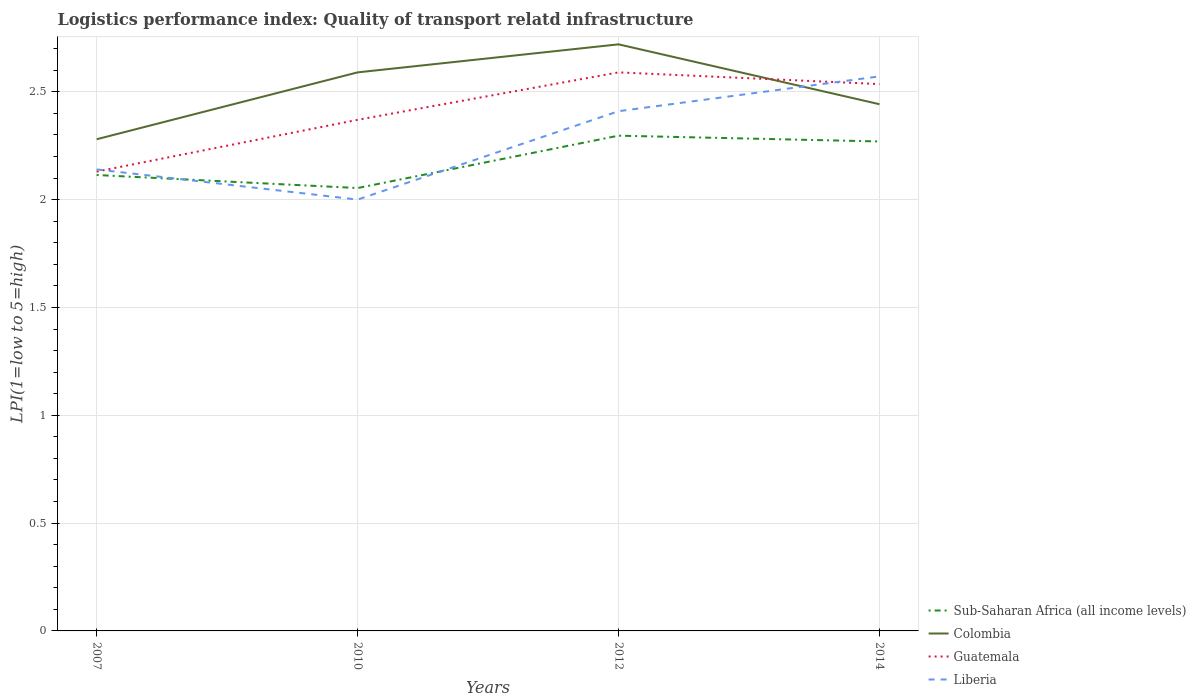Does the line corresponding to Guatemala intersect with the line corresponding to Sub-Saharan Africa (all income levels)?
Provide a short and direct response. No. Is the number of lines equal to the number of legend labels?
Your answer should be compact. Yes. In which year was the logistics performance index in Guatemala maximum?
Your answer should be very brief. 2007. What is the total logistics performance index in Liberia in the graph?
Ensure brevity in your answer.  -0.27. What is the difference between the highest and the second highest logistics performance index in Guatemala?
Offer a terse response. 0.46. What is the difference between the highest and the lowest logistics performance index in Sub-Saharan Africa (all income levels)?
Give a very brief answer. 2. Is the logistics performance index in Guatemala strictly greater than the logistics performance index in Sub-Saharan Africa (all income levels) over the years?
Give a very brief answer. No. What is the difference between two consecutive major ticks on the Y-axis?
Provide a short and direct response. 0.5. Are the values on the major ticks of Y-axis written in scientific E-notation?
Provide a succinct answer. No. Does the graph contain any zero values?
Make the answer very short. No. How many legend labels are there?
Your answer should be compact. 4. What is the title of the graph?
Give a very brief answer. Logistics performance index: Quality of transport relatd infrastructure. What is the label or title of the X-axis?
Make the answer very short. Years. What is the label or title of the Y-axis?
Your response must be concise. LPI(1=low to 5=high). What is the LPI(1=low to 5=high) of Sub-Saharan Africa (all income levels) in 2007?
Keep it short and to the point. 2.11. What is the LPI(1=low to 5=high) of Colombia in 2007?
Ensure brevity in your answer.  2.28. What is the LPI(1=low to 5=high) of Guatemala in 2007?
Keep it short and to the point. 2.13. What is the LPI(1=low to 5=high) in Liberia in 2007?
Ensure brevity in your answer.  2.14. What is the LPI(1=low to 5=high) of Sub-Saharan Africa (all income levels) in 2010?
Provide a succinct answer. 2.05. What is the LPI(1=low to 5=high) in Colombia in 2010?
Provide a short and direct response. 2.59. What is the LPI(1=low to 5=high) in Guatemala in 2010?
Provide a succinct answer. 2.37. What is the LPI(1=low to 5=high) of Sub-Saharan Africa (all income levels) in 2012?
Provide a short and direct response. 2.3. What is the LPI(1=low to 5=high) in Colombia in 2012?
Your answer should be compact. 2.72. What is the LPI(1=low to 5=high) of Guatemala in 2012?
Offer a very short reply. 2.59. What is the LPI(1=low to 5=high) in Liberia in 2012?
Offer a very short reply. 2.41. What is the LPI(1=low to 5=high) of Sub-Saharan Africa (all income levels) in 2014?
Offer a very short reply. 2.27. What is the LPI(1=low to 5=high) in Colombia in 2014?
Your answer should be compact. 2.44. What is the LPI(1=low to 5=high) in Guatemala in 2014?
Ensure brevity in your answer.  2.54. What is the LPI(1=low to 5=high) of Liberia in 2014?
Ensure brevity in your answer.  2.57. Across all years, what is the maximum LPI(1=low to 5=high) in Sub-Saharan Africa (all income levels)?
Ensure brevity in your answer.  2.3. Across all years, what is the maximum LPI(1=low to 5=high) of Colombia?
Give a very brief answer. 2.72. Across all years, what is the maximum LPI(1=low to 5=high) of Guatemala?
Provide a short and direct response. 2.59. Across all years, what is the maximum LPI(1=low to 5=high) in Liberia?
Provide a short and direct response. 2.57. Across all years, what is the minimum LPI(1=low to 5=high) in Sub-Saharan Africa (all income levels)?
Your answer should be very brief. 2.05. Across all years, what is the minimum LPI(1=low to 5=high) of Colombia?
Your answer should be very brief. 2.28. Across all years, what is the minimum LPI(1=low to 5=high) in Guatemala?
Your response must be concise. 2.13. Across all years, what is the minimum LPI(1=low to 5=high) in Liberia?
Offer a very short reply. 2. What is the total LPI(1=low to 5=high) in Sub-Saharan Africa (all income levels) in the graph?
Offer a terse response. 8.73. What is the total LPI(1=low to 5=high) in Colombia in the graph?
Provide a succinct answer. 10.03. What is the total LPI(1=low to 5=high) in Guatemala in the graph?
Your answer should be very brief. 9.63. What is the total LPI(1=low to 5=high) of Liberia in the graph?
Your answer should be compact. 9.12. What is the difference between the LPI(1=low to 5=high) of Sub-Saharan Africa (all income levels) in 2007 and that in 2010?
Offer a terse response. 0.06. What is the difference between the LPI(1=low to 5=high) of Colombia in 2007 and that in 2010?
Your response must be concise. -0.31. What is the difference between the LPI(1=low to 5=high) in Guatemala in 2007 and that in 2010?
Your response must be concise. -0.24. What is the difference between the LPI(1=low to 5=high) of Liberia in 2007 and that in 2010?
Your response must be concise. 0.14. What is the difference between the LPI(1=low to 5=high) of Sub-Saharan Africa (all income levels) in 2007 and that in 2012?
Make the answer very short. -0.18. What is the difference between the LPI(1=low to 5=high) of Colombia in 2007 and that in 2012?
Offer a very short reply. -0.44. What is the difference between the LPI(1=low to 5=high) in Guatemala in 2007 and that in 2012?
Offer a terse response. -0.46. What is the difference between the LPI(1=low to 5=high) of Liberia in 2007 and that in 2012?
Give a very brief answer. -0.27. What is the difference between the LPI(1=low to 5=high) in Sub-Saharan Africa (all income levels) in 2007 and that in 2014?
Keep it short and to the point. -0.16. What is the difference between the LPI(1=low to 5=high) in Colombia in 2007 and that in 2014?
Your answer should be very brief. -0.16. What is the difference between the LPI(1=low to 5=high) of Guatemala in 2007 and that in 2014?
Give a very brief answer. -0.41. What is the difference between the LPI(1=low to 5=high) in Liberia in 2007 and that in 2014?
Offer a very short reply. -0.43. What is the difference between the LPI(1=low to 5=high) of Sub-Saharan Africa (all income levels) in 2010 and that in 2012?
Make the answer very short. -0.24. What is the difference between the LPI(1=low to 5=high) in Colombia in 2010 and that in 2012?
Your answer should be compact. -0.13. What is the difference between the LPI(1=low to 5=high) of Guatemala in 2010 and that in 2012?
Your response must be concise. -0.22. What is the difference between the LPI(1=low to 5=high) in Liberia in 2010 and that in 2012?
Give a very brief answer. -0.41. What is the difference between the LPI(1=low to 5=high) in Sub-Saharan Africa (all income levels) in 2010 and that in 2014?
Your response must be concise. -0.22. What is the difference between the LPI(1=low to 5=high) in Colombia in 2010 and that in 2014?
Provide a short and direct response. 0.15. What is the difference between the LPI(1=low to 5=high) of Guatemala in 2010 and that in 2014?
Keep it short and to the point. -0.17. What is the difference between the LPI(1=low to 5=high) of Liberia in 2010 and that in 2014?
Offer a very short reply. -0.57. What is the difference between the LPI(1=low to 5=high) of Sub-Saharan Africa (all income levels) in 2012 and that in 2014?
Ensure brevity in your answer.  0.03. What is the difference between the LPI(1=low to 5=high) in Colombia in 2012 and that in 2014?
Your answer should be compact. 0.28. What is the difference between the LPI(1=low to 5=high) of Guatemala in 2012 and that in 2014?
Offer a very short reply. 0.05. What is the difference between the LPI(1=low to 5=high) of Liberia in 2012 and that in 2014?
Your response must be concise. -0.16. What is the difference between the LPI(1=low to 5=high) of Sub-Saharan Africa (all income levels) in 2007 and the LPI(1=low to 5=high) of Colombia in 2010?
Provide a short and direct response. -0.48. What is the difference between the LPI(1=low to 5=high) of Sub-Saharan Africa (all income levels) in 2007 and the LPI(1=low to 5=high) of Guatemala in 2010?
Provide a succinct answer. -0.26. What is the difference between the LPI(1=low to 5=high) of Sub-Saharan Africa (all income levels) in 2007 and the LPI(1=low to 5=high) of Liberia in 2010?
Your answer should be compact. 0.11. What is the difference between the LPI(1=low to 5=high) of Colombia in 2007 and the LPI(1=low to 5=high) of Guatemala in 2010?
Offer a very short reply. -0.09. What is the difference between the LPI(1=low to 5=high) of Colombia in 2007 and the LPI(1=low to 5=high) of Liberia in 2010?
Offer a very short reply. 0.28. What is the difference between the LPI(1=low to 5=high) of Guatemala in 2007 and the LPI(1=low to 5=high) of Liberia in 2010?
Give a very brief answer. 0.13. What is the difference between the LPI(1=low to 5=high) in Sub-Saharan Africa (all income levels) in 2007 and the LPI(1=low to 5=high) in Colombia in 2012?
Your answer should be very brief. -0.61. What is the difference between the LPI(1=low to 5=high) in Sub-Saharan Africa (all income levels) in 2007 and the LPI(1=low to 5=high) in Guatemala in 2012?
Your answer should be very brief. -0.48. What is the difference between the LPI(1=low to 5=high) of Sub-Saharan Africa (all income levels) in 2007 and the LPI(1=low to 5=high) of Liberia in 2012?
Provide a succinct answer. -0.3. What is the difference between the LPI(1=low to 5=high) of Colombia in 2007 and the LPI(1=low to 5=high) of Guatemala in 2012?
Keep it short and to the point. -0.31. What is the difference between the LPI(1=low to 5=high) in Colombia in 2007 and the LPI(1=low to 5=high) in Liberia in 2012?
Your response must be concise. -0.13. What is the difference between the LPI(1=low to 5=high) of Guatemala in 2007 and the LPI(1=low to 5=high) of Liberia in 2012?
Offer a terse response. -0.28. What is the difference between the LPI(1=low to 5=high) in Sub-Saharan Africa (all income levels) in 2007 and the LPI(1=low to 5=high) in Colombia in 2014?
Your answer should be very brief. -0.33. What is the difference between the LPI(1=low to 5=high) in Sub-Saharan Africa (all income levels) in 2007 and the LPI(1=low to 5=high) in Guatemala in 2014?
Keep it short and to the point. -0.42. What is the difference between the LPI(1=low to 5=high) of Sub-Saharan Africa (all income levels) in 2007 and the LPI(1=low to 5=high) of Liberia in 2014?
Offer a terse response. -0.46. What is the difference between the LPI(1=low to 5=high) in Colombia in 2007 and the LPI(1=low to 5=high) in Guatemala in 2014?
Your answer should be compact. -0.26. What is the difference between the LPI(1=low to 5=high) in Colombia in 2007 and the LPI(1=low to 5=high) in Liberia in 2014?
Ensure brevity in your answer.  -0.29. What is the difference between the LPI(1=low to 5=high) in Guatemala in 2007 and the LPI(1=low to 5=high) in Liberia in 2014?
Offer a terse response. -0.44. What is the difference between the LPI(1=low to 5=high) in Sub-Saharan Africa (all income levels) in 2010 and the LPI(1=low to 5=high) in Colombia in 2012?
Provide a succinct answer. -0.67. What is the difference between the LPI(1=low to 5=high) in Sub-Saharan Africa (all income levels) in 2010 and the LPI(1=low to 5=high) in Guatemala in 2012?
Provide a short and direct response. -0.54. What is the difference between the LPI(1=low to 5=high) of Sub-Saharan Africa (all income levels) in 2010 and the LPI(1=low to 5=high) of Liberia in 2012?
Make the answer very short. -0.36. What is the difference between the LPI(1=low to 5=high) of Colombia in 2010 and the LPI(1=low to 5=high) of Guatemala in 2012?
Your answer should be very brief. 0. What is the difference between the LPI(1=low to 5=high) in Colombia in 2010 and the LPI(1=low to 5=high) in Liberia in 2012?
Offer a terse response. 0.18. What is the difference between the LPI(1=low to 5=high) of Guatemala in 2010 and the LPI(1=low to 5=high) of Liberia in 2012?
Make the answer very short. -0.04. What is the difference between the LPI(1=low to 5=high) in Sub-Saharan Africa (all income levels) in 2010 and the LPI(1=low to 5=high) in Colombia in 2014?
Offer a very short reply. -0.39. What is the difference between the LPI(1=low to 5=high) in Sub-Saharan Africa (all income levels) in 2010 and the LPI(1=low to 5=high) in Guatemala in 2014?
Offer a terse response. -0.48. What is the difference between the LPI(1=low to 5=high) of Sub-Saharan Africa (all income levels) in 2010 and the LPI(1=low to 5=high) of Liberia in 2014?
Your answer should be very brief. -0.52. What is the difference between the LPI(1=low to 5=high) in Colombia in 2010 and the LPI(1=low to 5=high) in Guatemala in 2014?
Give a very brief answer. 0.05. What is the difference between the LPI(1=low to 5=high) in Colombia in 2010 and the LPI(1=low to 5=high) in Liberia in 2014?
Offer a very short reply. 0.02. What is the difference between the LPI(1=low to 5=high) in Guatemala in 2010 and the LPI(1=low to 5=high) in Liberia in 2014?
Provide a short and direct response. -0.2. What is the difference between the LPI(1=low to 5=high) of Sub-Saharan Africa (all income levels) in 2012 and the LPI(1=low to 5=high) of Colombia in 2014?
Your response must be concise. -0.15. What is the difference between the LPI(1=low to 5=high) in Sub-Saharan Africa (all income levels) in 2012 and the LPI(1=low to 5=high) in Guatemala in 2014?
Keep it short and to the point. -0.24. What is the difference between the LPI(1=low to 5=high) of Sub-Saharan Africa (all income levels) in 2012 and the LPI(1=low to 5=high) of Liberia in 2014?
Offer a terse response. -0.27. What is the difference between the LPI(1=low to 5=high) in Colombia in 2012 and the LPI(1=low to 5=high) in Guatemala in 2014?
Ensure brevity in your answer.  0.18. What is the difference between the LPI(1=low to 5=high) of Colombia in 2012 and the LPI(1=low to 5=high) of Liberia in 2014?
Keep it short and to the point. 0.15. What is the difference between the LPI(1=low to 5=high) in Guatemala in 2012 and the LPI(1=low to 5=high) in Liberia in 2014?
Your response must be concise. 0.02. What is the average LPI(1=low to 5=high) in Sub-Saharan Africa (all income levels) per year?
Provide a succinct answer. 2.18. What is the average LPI(1=low to 5=high) of Colombia per year?
Provide a succinct answer. 2.51. What is the average LPI(1=low to 5=high) of Guatemala per year?
Your response must be concise. 2.41. What is the average LPI(1=low to 5=high) in Liberia per year?
Your answer should be compact. 2.28. In the year 2007, what is the difference between the LPI(1=low to 5=high) in Sub-Saharan Africa (all income levels) and LPI(1=low to 5=high) in Colombia?
Your answer should be compact. -0.17. In the year 2007, what is the difference between the LPI(1=low to 5=high) in Sub-Saharan Africa (all income levels) and LPI(1=low to 5=high) in Guatemala?
Your answer should be compact. -0.02. In the year 2007, what is the difference between the LPI(1=low to 5=high) of Sub-Saharan Africa (all income levels) and LPI(1=low to 5=high) of Liberia?
Give a very brief answer. -0.03. In the year 2007, what is the difference between the LPI(1=low to 5=high) in Colombia and LPI(1=low to 5=high) in Guatemala?
Your answer should be compact. 0.15. In the year 2007, what is the difference between the LPI(1=low to 5=high) of Colombia and LPI(1=low to 5=high) of Liberia?
Your answer should be compact. 0.14. In the year 2007, what is the difference between the LPI(1=low to 5=high) of Guatemala and LPI(1=low to 5=high) of Liberia?
Your answer should be compact. -0.01. In the year 2010, what is the difference between the LPI(1=low to 5=high) of Sub-Saharan Africa (all income levels) and LPI(1=low to 5=high) of Colombia?
Offer a very short reply. -0.54. In the year 2010, what is the difference between the LPI(1=low to 5=high) of Sub-Saharan Africa (all income levels) and LPI(1=low to 5=high) of Guatemala?
Your answer should be very brief. -0.32. In the year 2010, what is the difference between the LPI(1=low to 5=high) of Sub-Saharan Africa (all income levels) and LPI(1=low to 5=high) of Liberia?
Your response must be concise. 0.05. In the year 2010, what is the difference between the LPI(1=low to 5=high) of Colombia and LPI(1=low to 5=high) of Guatemala?
Your answer should be very brief. 0.22. In the year 2010, what is the difference between the LPI(1=low to 5=high) of Colombia and LPI(1=low to 5=high) of Liberia?
Provide a short and direct response. 0.59. In the year 2010, what is the difference between the LPI(1=low to 5=high) in Guatemala and LPI(1=low to 5=high) in Liberia?
Provide a short and direct response. 0.37. In the year 2012, what is the difference between the LPI(1=low to 5=high) in Sub-Saharan Africa (all income levels) and LPI(1=low to 5=high) in Colombia?
Provide a short and direct response. -0.42. In the year 2012, what is the difference between the LPI(1=low to 5=high) of Sub-Saharan Africa (all income levels) and LPI(1=low to 5=high) of Guatemala?
Provide a short and direct response. -0.29. In the year 2012, what is the difference between the LPI(1=low to 5=high) of Sub-Saharan Africa (all income levels) and LPI(1=low to 5=high) of Liberia?
Make the answer very short. -0.11. In the year 2012, what is the difference between the LPI(1=low to 5=high) of Colombia and LPI(1=low to 5=high) of Guatemala?
Keep it short and to the point. 0.13. In the year 2012, what is the difference between the LPI(1=low to 5=high) in Colombia and LPI(1=low to 5=high) in Liberia?
Offer a very short reply. 0.31. In the year 2012, what is the difference between the LPI(1=low to 5=high) of Guatemala and LPI(1=low to 5=high) of Liberia?
Keep it short and to the point. 0.18. In the year 2014, what is the difference between the LPI(1=low to 5=high) in Sub-Saharan Africa (all income levels) and LPI(1=low to 5=high) in Colombia?
Your answer should be very brief. -0.17. In the year 2014, what is the difference between the LPI(1=low to 5=high) of Sub-Saharan Africa (all income levels) and LPI(1=low to 5=high) of Guatemala?
Your answer should be compact. -0.27. In the year 2014, what is the difference between the LPI(1=low to 5=high) in Sub-Saharan Africa (all income levels) and LPI(1=low to 5=high) in Liberia?
Ensure brevity in your answer.  -0.3. In the year 2014, what is the difference between the LPI(1=low to 5=high) in Colombia and LPI(1=low to 5=high) in Guatemala?
Ensure brevity in your answer.  -0.09. In the year 2014, what is the difference between the LPI(1=low to 5=high) of Colombia and LPI(1=low to 5=high) of Liberia?
Keep it short and to the point. -0.13. In the year 2014, what is the difference between the LPI(1=low to 5=high) of Guatemala and LPI(1=low to 5=high) of Liberia?
Ensure brevity in your answer.  -0.04. What is the ratio of the LPI(1=low to 5=high) of Sub-Saharan Africa (all income levels) in 2007 to that in 2010?
Offer a terse response. 1.03. What is the ratio of the LPI(1=low to 5=high) in Colombia in 2007 to that in 2010?
Keep it short and to the point. 0.88. What is the ratio of the LPI(1=low to 5=high) in Guatemala in 2007 to that in 2010?
Give a very brief answer. 0.9. What is the ratio of the LPI(1=low to 5=high) in Liberia in 2007 to that in 2010?
Make the answer very short. 1.07. What is the ratio of the LPI(1=low to 5=high) of Sub-Saharan Africa (all income levels) in 2007 to that in 2012?
Give a very brief answer. 0.92. What is the ratio of the LPI(1=low to 5=high) in Colombia in 2007 to that in 2012?
Your answer should be compact. 0.84. What is the ratio of the LPI(1=low to 5=high) of Guatemala in 2007 to that in 2012?
Provide a succinct answer. 0.82. What is the ratio of the LPI(1=low to 5=high) in Liberia in 2007 to that in 2012?
Offer a terse response. 0.89. What is the ratio of the LPI(1=low to 5=high) of Sub-Saharan Africa (all income levels) in 2007 to that in 2014?
Your answer should be very brief. 0.93. What is the ratio of the LPI(1=low to 5=high) in Colombia in 2007 to that in 2014?
Provide a succinct answer. 0.93. What is the ratio of the LPI(1=low to 5=high) in Guatemala in 2007 to that in 2014?
Your answer should be compact. 0.84. What is the ratio of the LPI(1=low to 5=high) in Liberia in 2007 to that in 2014?
Make the answer very short. 0.83. What is the ratio of the LPI(1=low to 5=high) in Sub-Saharan Africa (all income levels) in 2010 to that in 2012?
Provide a succinct answer. 0.89. What is the ratio of the LPI(1=low to 5=high) in Colombia in 2010 to that in 2012?
Your answer should be compact. 0.95. What is the ratio of the LPI(1=low to 5=high) of Guatemala in 2010 to that in 2012?
Make the answer very short. 0.92. What is the ratio of the LPI(1=low to 5=high) of Liberia in 2010 to that in 2012?
Your response must be concise. 0.83. What is the ratio of the LPI(1=low to 5=high) of Sub-Saharan Africa (all income levels) in 2010 to that in 2014?
Offer a very short reply. 0.9. What is the ratio of the LPI(1=low to 5=high) in Colombia in 2010 to that in 2014?
Offer a very short reply. 1.06. What is the ratio of the LPI(1=low to 5=high) of Guatemala in 2010 to that in 2014?
Keep it short and to the point. 0.93. What is the ratio of the LPI(1=low to 5=high) in Sub-Saharan Africa (all income levels) in 2012 to that in 2014?
Offer a very short reply. 1.01. What is the ratio of the LPI(1=low to 5=high) in Colombia in 2012 to that in 2014?
Your answer should be compact. 1.11. What is the ratio of the LPI(1=low to 5=high) of Guatemala in 2012 to that in 2014?
Offer a very short reply. 1.02. What is the ratio of the LPI(1=low to 5=high) in Liberia in 2012 to that in 2014?
Offer a very short reply. 0.94. What is the difference between the highest and the second highest LPI(1=low to 5=high) of Sub-Saharan Africa (all income levels)?
Provide a short and direct response. 0.03. What is the difference between the highest and the second highest LPI(1=low to 5=high) of Colombia?
Your answer should be very brief. 0.13. What is the difference between the highest and the second highest LPI(1=low to 5=high) of Guatemala?
Provide a short and direct response. 0.05. What is the difference between the highest and the second highest LPI(1=low to 5=high) of Liberia?
Offer a very short reply. 0.16. What is the difference between the highest and the lowest LPI(1=low to 5=high) in Sub-Saharan Africa (all income levels)?
Give a very brief answer. 0.24. What is the difference between the highest and the lowest LPI(1=low to 5=high) in Colombia?
Your response must be concise. 0.44. What is the difference between the highest and the lowest LPI(1=low to 5=high) of Guatemala?
Offer a very short reply. 0.46. What is the difference between the highest and the lowest LPI(1=low to 5=high) in Liberia?
Offer a terse response. 0.57. 